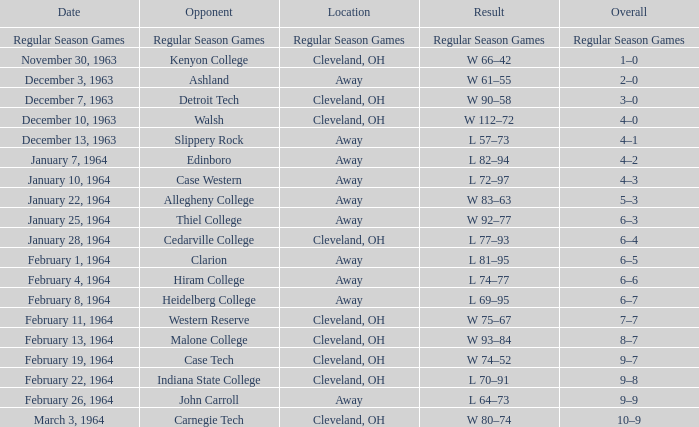What is the date with an opposing team that is indiana state college? February 22, 1964. Could you parse the entire table as a dict? {'header': ['Date', 'Opponent', 'Location', 'Result', 'Overall'], 'rows': [['Regular Season Games', 'Regular Season Games', 'Regular Season Games', 'Regular Season Games', 'Regular Season Games'], ['November 30, 1963', 'Kenyon College', 'Cleveland, OH', 'W 66–42', '1–0'], ['December 3, 1963', 'Ashland', 'Away', 'W 61–55', '2–0'], ['December 7, 1963', 'Detroit Tech', 'Cleveland, OH', 'W 90–58', '3–0'], ['December 10, 1963', 'Walsh', 'Cleveland, OH', 'W 112–72', '4–0'], ['December 13, 1963', 'Slippery Rock', 'Away', 'L 57–73', '4–1'], ['January 7, 1964', 'Edinboro', 'Away', 'L 82–94', '4–2'], ['January 10, 1964', 'Case Western', 'Away', 'L 72–97', '4–3'], ['January 22, 1964', 'Allegheny College', 'Away', 'W 83–63', '5–3'], ['January 25, 1964', 'Thiel College', 'Away', 'W 92–77', '6–3'], ['January 28, 1964', 'Cedarville College', 'Cleveland, OH', 'L 77–93', '6–4'], ['February 1, 1964', 'Clarion', 'Away', 'L 81–95', '6–5'], ['February 4, 1964', 'Hiram College', 'Away', 'L 74–77', '6–6'], ['February 8, 1964', 'Heidelberg College', 'Away', 'L 69–95', '6–7'], ['February 11, 1964', 'Western Reserve', 'Cleveland, OH', 'W 75–67', '7–7'], ['February 13, 1964', 'Malone College', 'Cleveland, OH', 'W 93–84', '8–7'], ['February 19, 1964', 'Case Tech', 'Cleveland, OH', 'W 74–52', '9–7'], ['February 22, 1964', 'Indiana State College', 'Cleveland, OH', 'L 70–91', '9–8'], ['February 26, 1964', 'John Carroll', 'Away', 'L 64–73', '9–9'], ['March 3, 1964', 'Carnegie Tech', 'Cleveland, OH', 'W 80–74', '10–9']]} 